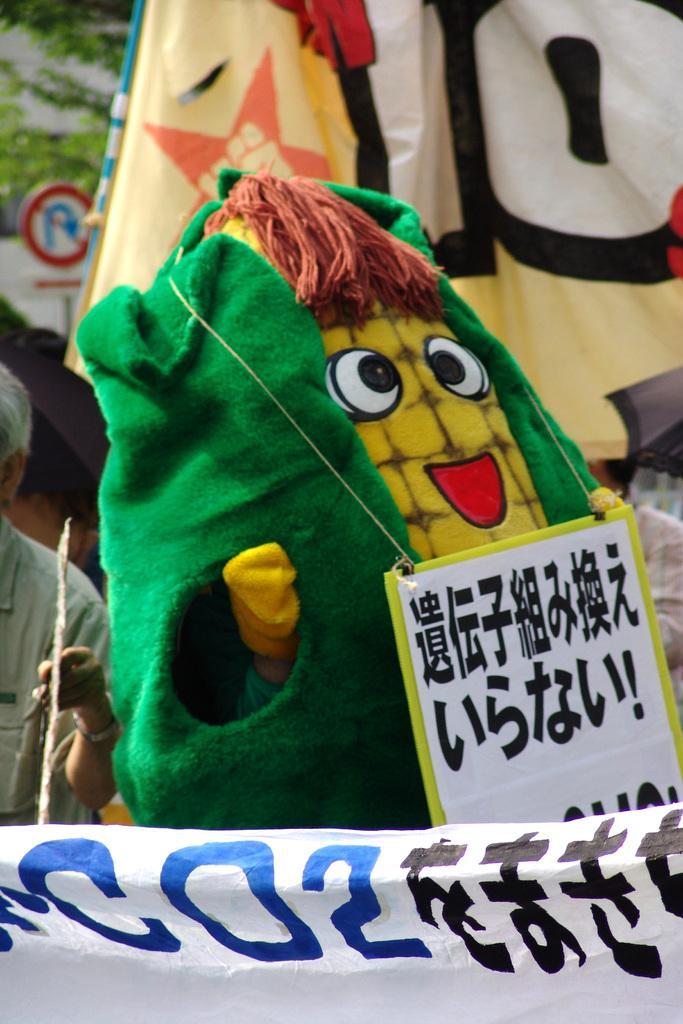Please provide a concise description of this image. In this image we can see a toy, there a person is standing, there is the banner, at back there is the sign board. 